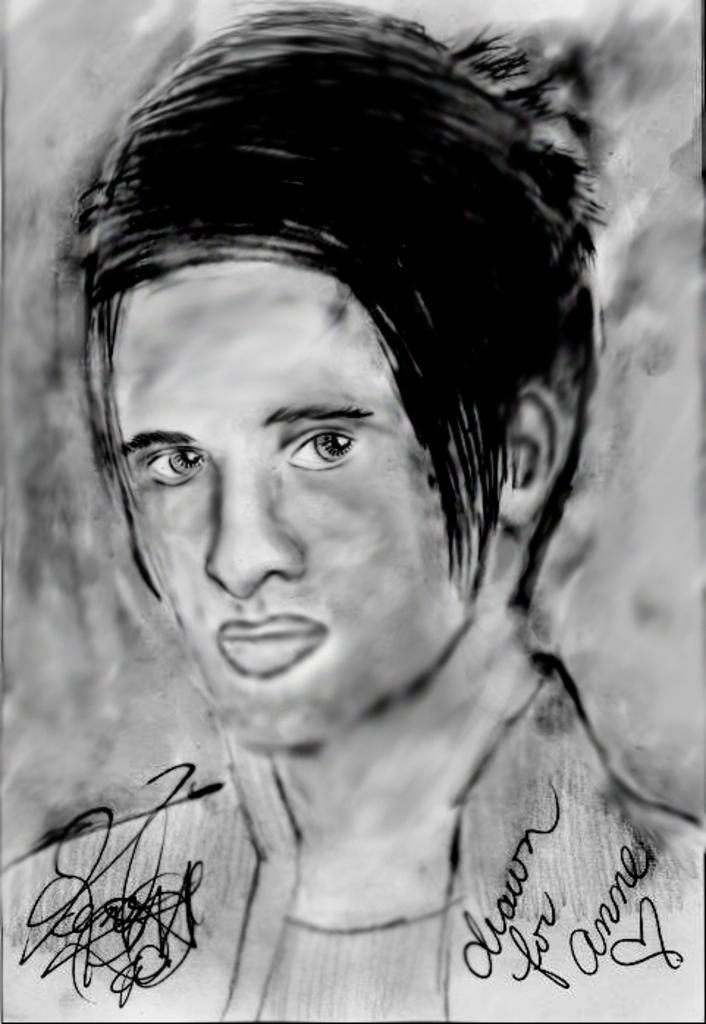Could you give a brief overview of what you see in this image? In this picture we can see drawing of a man and some text. 